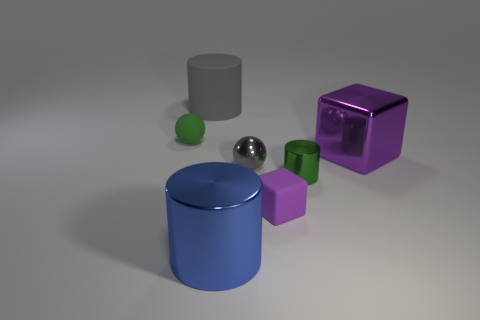How many things are either rubber things that are to the right of the small shiny sphere or small gray spheres?
Offer a terse response. 2. Is the number of large blocks that are behind the tiny green rubber sphere greater than the number of big gray matte cylinders that are in front of the tiny gray metallic ball?
Your answer should be very brief. No. There is a rubber cylinder that is the same color as the tiny metallic ball; what is its size?
Offer a very short reply. Large. Do the purple shiny thing and the green thing behind the big block have the same size?
Your response must be concise. No. What number of spheres are either small rubber things or large shiny things?
Provide a succinct answer. 1. There is a blue cylinder that is the same material as the large purple block; what size is it?
Provide a succinct answer. Large. There is a green object behind the tiny shiny cylinder; does it have the same size as the rubber object in front of the large purple metal cube?
Your answer should be compact. Yes. How many objects are either green rubber objects or gray cylinders?
Offer a very short reply. 2. The blue metallic object has what shape?
Offer a very short reply. Cylinder. What is the size of the matte thing that is the same shape as the small green shiny thing?
Your response must be concise. Large. 